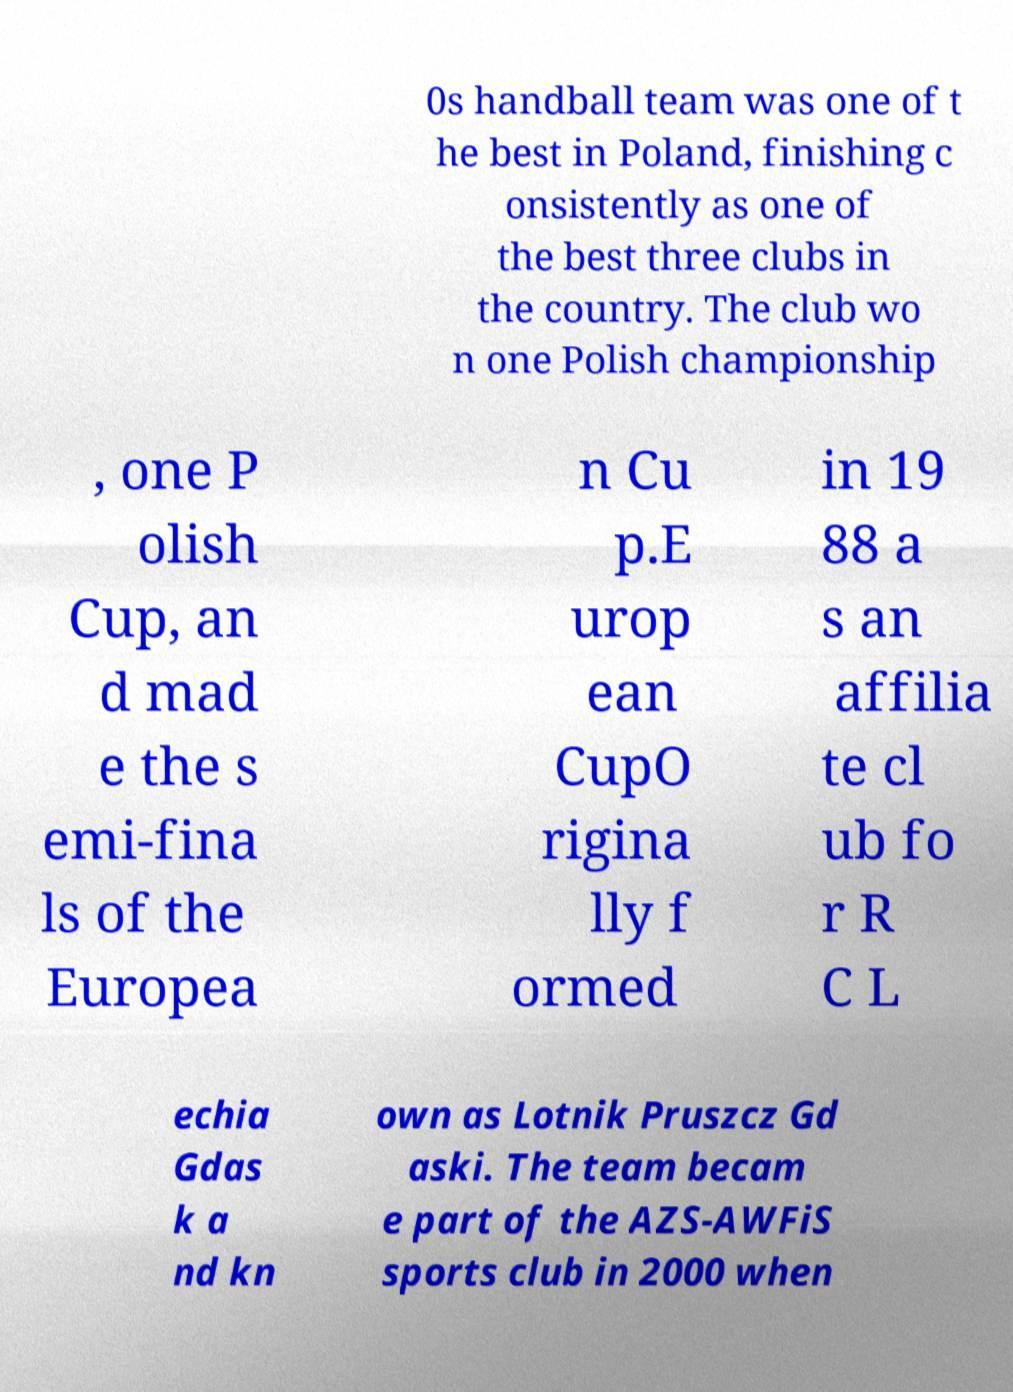I need the written content from this picture converted into text. Can you do that? 0s handball team was one of t he best in Poland, finishing c onsistently as one of the best three clubs in the country. The club wo n one Polish championship , one P olish Cup, an d mad e the s emi-fina ls of the Europea n Cu p.E urop ean CupO rigina lly f ormed in 19 88 a s an affilia te cl ub fo r R C L echia Gdas k a nd kn own as Lotnik Pruszcz Gd aski. The team becam e part of the AZS-AWFiS sports club in 2000 when 